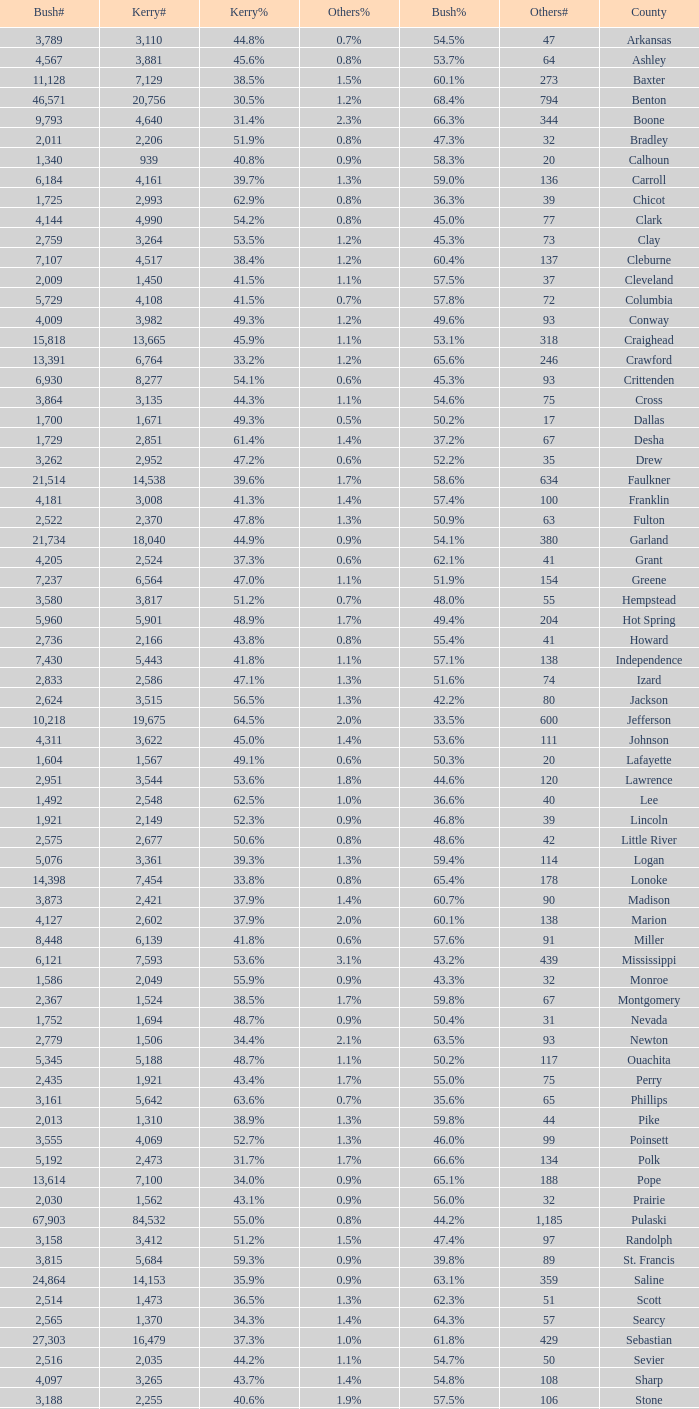Can you parse all the data within this table? {'header': ['Bush#', 'Kerry#', 'Kerry%', 'Others%', 'Bush%', 'Others#', 'County'], 'rows': [['3,789', '3,110', '44.8%', '0.7%', '54.5%', '47', 'Arkansas'], ['4,567', '3,881', '45.6%', '0.8%', '53.7%', '64', 'Ashley'], ['11,128', '7,129', '38.5%', '1.5%', '60.1%', '273', 'Baxter'], ['46,571', '20,756', '30.5%', '1.2%', '68.4%', '794', 'Benton'], ['9,793', '4,640', '31.4%', '2.3%', '66.3%', '344', 'Boone'], ['2,011', '2,206', '51.9%', '0.8%', '47.3%', '32', 'Bradley'], ['1,340', '939', '40.8%', '0.9%', '58.3%', '20', 'Calhoun'], ['6,184', '4,161', '39.7%', '1.3%', '59.0%', '136', 'Carroll'], ['1,725', '2,993', '62.9%', '0.8%', '36.3%', '39', 'Chicot'], ['4,144', '4,990', '54.2%', '0.8%', '45.0%', '77', 'Clark'], ['2,759', '3,264', '53.5%', '1.2%', '45.3%', '73', 'Clay'], ['7,107', '4,517', '38.4%', '1.2%', '60.4%', '137', 'Cleburne'], ['2,009', '1,450', '41.5%', '1.1%', '57.5%', '37', 'Cleveland'], ['5,729', '4,108', '41.5%', '0.7%', '57.8%', '72', 'Columbia'], ['4,009', '3,982', '49.3%', '1.2%', '49.6%', '93', 'Conway'], ['15,818', '13,665', '45.9%', '1.1%', '53.1%', '318', 'Craighead'], ['13,391', '6,764', '33.2%', '1.2%', '65.6%', '246', 'Crawford'], ['6,930', '8,277', '54.1%', '0.6%', '45.3%', '93', 'Crittenden'], ['3,864', '3,135', '44.3%', '1.1%', '54.6%', '75', 'Cross'], ['1,700', '1,671', '49.3%', '0.5%', '50.2%', '17', 'Dallas'], ['1,729', '2,851', '61.4%', '1.4%', '37.2%', '67', 'Desha'], ['3,262', '2,952', '47.2%', '0.6%', '52.2%', '35', 'Drew'], ['21,514', '14,538', '39.6%', '1.7%', '58.6%', '634', 'Faulkner'], ['4,181', '3,008', '41.3%', '1.4%', '57.4%', '100', 'Franklin'], ['2,522', '2,370', '47.8%', '1.3%', '50.9%', '63', 'Fulton'], ['21,734', '18,040', '44.9%', '0.9%', '54.1%', '380', 'Garland'], ['4,205', '2,524', '37.3%', '0.6%', '62.1%', '41', 'Grant'], ['7,237', '6,564', '47.0%', '1.1%', '51.9%', '154', 'Greene'], ['3,580', '3,817', '51.2%', '0.7%', '48.0%', '55', 'Hempstead'], ['5,960', '5,901', '48.9%', '1.7%', '49.4%', '204', 'Hot Spring'], ['2,736', '2,166', '43.8%', '0.8%', '55.4%', '41', 'Howard'], ['7,430', '5,443', '41.8%', '1.1%', '57.1%', '138', 'Independence'], ['2,833', '2,586', '47.1%', '1.3%', '51.6%', '74', 'Izard'], ['2,624', '3,515', '56.5%', '1.3%', '42.2%', '80', 'Jackson'], ['10,218', '19,675', '64.5%', '2.0%', '33.5%', '600', 'Jefferson'], ['4,311', '3,622', '45.0%', '1.4%', '53.6%', '111', 'Johnson'], ['1,604', '1,567', '49.1%', '0.6%', '50.3%', '20', 'Lafayette'], ['2,951', '3,544', '53.6%', '1.8%', '44.6%', '120', 'Lawrence'], ['1,492', '2,548', '62.5%', '1.0%', '36.6%', '40', 'Lee'], ['1,921', '2,149', '52.3%', '0.9%', '46.8%', '39', 'Lincoln'], ['2,575', '2,677', '50.6%', '0.8%', '48.6%', '42', 'Little River'], ['5,076', '3,361', '39.3%', '1.3%', '59.4%', '114', 'Logan'], ['14,398', '7,454', '33.8%', '0.8%', '65.4%', '178', 'Lonoke'], ['3,873', '2,421', '37.9%', '1.4%', '60.7%', '90', 'Madison'], ['4,127', '2,602', '37.9%', '2.0%', '60.1%', '138', 'Marion'], ['8,448', '6,139', '41.8%', '0.6%', '57.6%', '91', 'Miller'], ['6,121', '7,593', '53.6%', '3.1%', '43.2%', '439', 'Mississippi'], ['1,586', '2,049', '55.9%', '0.9%', '43.3%', '32', 'Monroe'], ['2,367', '1,524', '38.5%', '1.7%', '59.8%', '67', 'Montgomery'], ['1,752', '1,694', '48.7%', '0.9%', '50.4%', '31', 'Nevada'], ['2,779', '1,506', '34.4%', '2.1%', '63.5%', '93', 'Newton'], ['5,345', '5,188', '48.7%', '1.1%', '50.2%', '117', 'Ouachita'], ['2,435', '1,921', '43.4%', '1.7%', '55.0%', '75', 'Perry'], ['3,161', '5,642', '63.6%', '0.7%', '35.6%', '65', 'Phillips'], ['2,013', '1,310', '38.9%', '1.3%', '59.8%', '44', 'Pike'], ['3,555', '4,069', '52.7%', '1.3%', '46.0%', '99', 'Poinsett'], ['5,192', '2,473', '31.7%', '1.7%', '66.6%', '134', 'Polk'], ['13,614', '7,100', '34.0%', '0.9%', '65.1%', '188', 'Pope'], ['2,030', '1,562', '43.1%', '0.9%', '56.0%', '32', 'Prairie'], ['67,903', '84,532', '55.0%', '0.8%', '44.2%', '1,185', 'Pulaski'], ['3,158', '3,412', '51.2%', '1.5%', '47.4%', '97', 'Randolph'], ['3,815', '5,684', '59.3%', '0.9%', '39.8%', '89', 'St. Francis'], ['24,864', '14,153', '35.9%', '0.9%', '63.1%', '359', 'Saline'], ['2,514', '1,473', '36.5%', '1.3%', '62.3%', '51', 'Scott'], ['2,565', '1,370', '34.3%', '1.4%', '64.3%', '57', 'Searcy'], ['27,303', '16,479', '37.3%', '1.0%', '61.8%', '429', 'Sebastian'], ['2,516', '2,035', '44.2%', '1.1%', '54.7%', '50', 'Sevier'], ['4,097', '3,265', '43.7%', '1.4%', '54.8%', '108', 'Sharp'], ['3,188', '2,255', '40.6%', '1.9%', '57.5%', '106', 'Stone'], ['10,502', '7,071', '39.7%', '1.5%', '58.9%', '259', 'Union'], ['3,988', '3,310', '44.9%', '1.0%', '54.1%', '76', 'Van Buren'], ['35,726', '27,597', '43.1%', '1.2%', '55.7%', '780', 'Washington'], ['17,001', '9,129', '34.5%', '1.1%', '64.3%', '295', 'White'], ['1,021', '1,972', '65.2%', '1.1%', '33.7%', '33', 'Woodruff'], ['3,678', '2,913', '43.7%', '1.0%', '55.2%', '68', 'Yell']]} What is the highest Bush#, when Others% is "1.7%", when Others# is less than 75, and when Kerry# is greater than 1,524? None. 